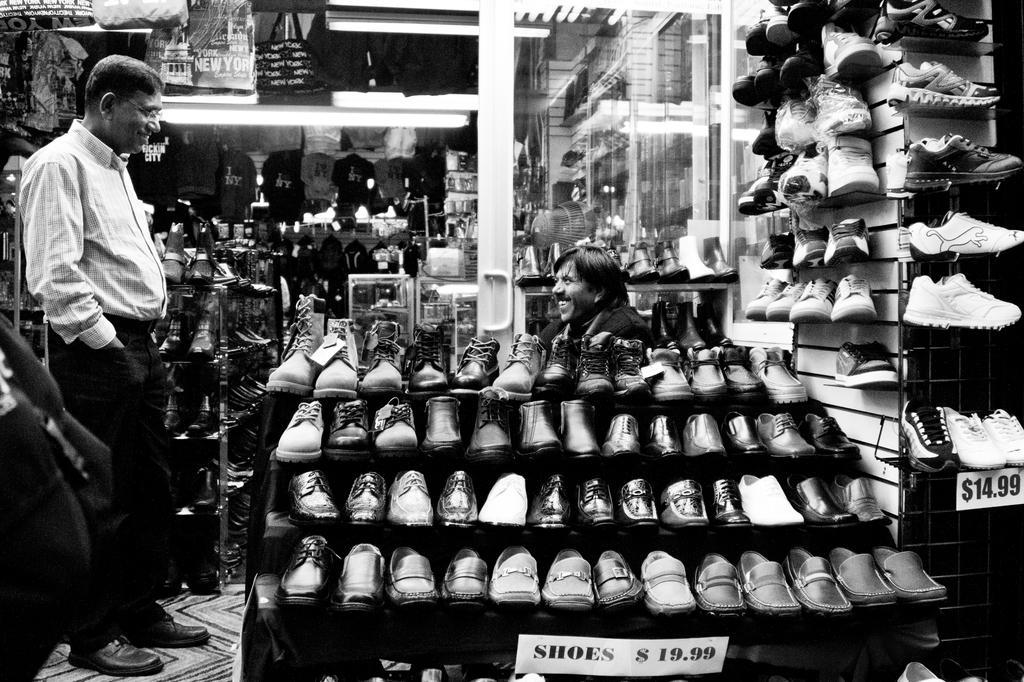Please provide a concise description of this image. This is a black and white picture. In front of the picture, we see a stepped table on which many shoes are placed. Behind that, we see a man is sitting on the chair and he is smiling. On the left side, we see a man is standing and he is smiling. Beside him, we see a rack in which many shoes are placed. On the right side, we see a rack in which many shoes are placed and below that, we see the price tag. In the background, we see the bags and shoes. We even see the mirror. This picture is clicked in the footwear shop. 